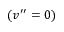Convert formula to latex. <formula><loc_0><loc_0><loc_500><loc_500>( v ^ { \prime \prime } = 0 )</formula> 